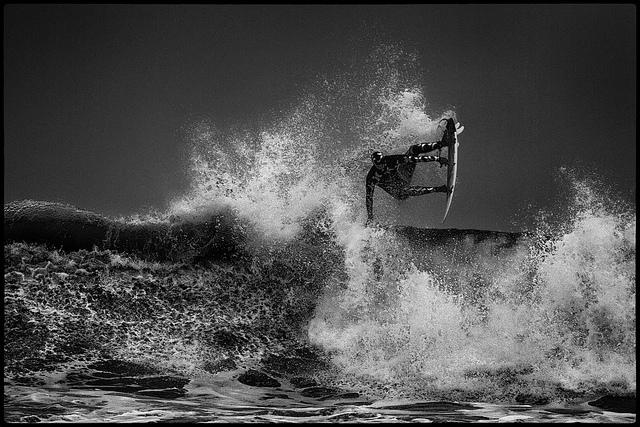Which of the surfer's limbs is almost parallel with the board?
Give a very brief answer. Legs. What caused the wave to be so uneven?
Quick response, please. Surfer. How many feet does the surfer have touching the board?
Concise answer only. 2. 